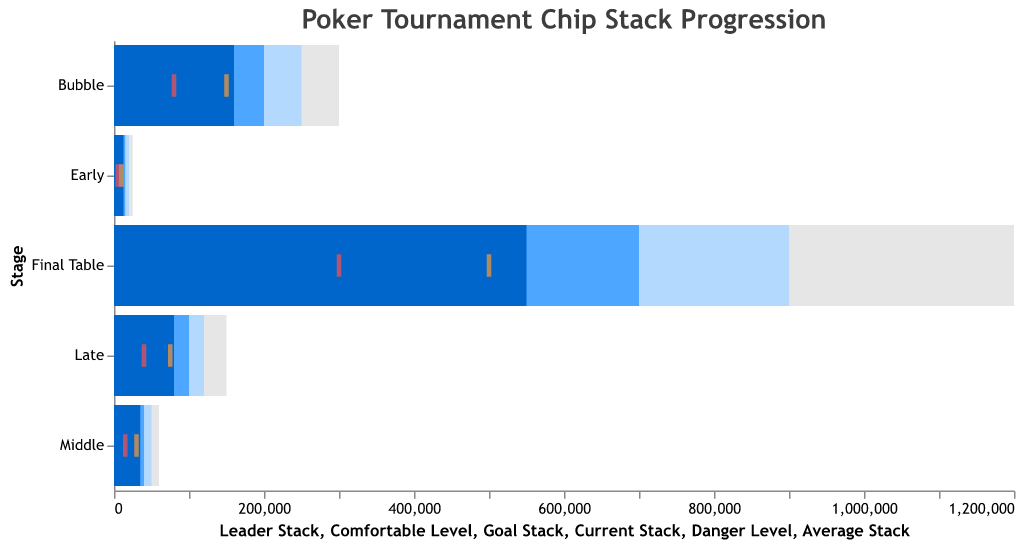What is the title of the figure? The title of the figure is displayed at the top and it reads "Poker Tournament Chip Stack Progression".
Answer: Poker Tournament Chip Stack Progression What color represents the Current Stack in the figure? The Current Stack is represented by a bar which is colored in a darker blue compared to others.
Answer: Darker blue Which stage has the highest Leader Stack value? Referring to the Leader Stack values on the horizontal axis, the Final Table stage has the highest Leader Stack value of 1,200,000.
Answer: Final Table What is the difference between Average Stack and Current Stack in the Middle stage? In the Middle stage, the Average Stack is 30,000 and the Current Stack is 35,000. The difference is 35,000 - 30,000 = 5,000.
Answer: 5,000 Which stages have a Danger Level of 80,000 or more? The stages with a Danger Level of 80,000 or more are Bubble (80,000) and Final Table (300,000).
Answer: Bubble, Final Table How does the Current Stack in the Late stage compare to the Comfortable Level in the Early stage? The Current Stack in the Late stage is 80,000, while the Comfortable Level in the Early stage is 20,000. 80,000 is greater than 20,000.
Answer: Greater than What is the Goal Stack during the Bubble stage? The Goal Stack during the Bubble stage is located at the horizontal bar labeled as 200,000.
Answer: 200,000 Arrange the stages in ascending order based on their Average Stack value. The stages in ascending order based on their Average Stack value are: Early (10,000), Middle (30,000), Late (75,000), Bubble (150,000), Final Table (500,000).
Answer: Early, Middle, Late, Bubble, Final Table Which levels have the Current Stack exceeding Goal Stack value? The goal can be visually confirmed by checking if the Current Stack bar (dark blue) exceeds the Goal Stack bar (lighter blue). Only the Early stage meets this criterion with Current Stack (12,500) exceeding Goal Stack (15,000).
Answer: Early What is the difference between the Leader Stack and the Comfortable Level in the Late stage? In the Late stage, the Leader Stack is 150,000 and the Comfortable Level is 120,000. The difference is 150,000 - 120,000 = 30,000.
Answer: 30,000 